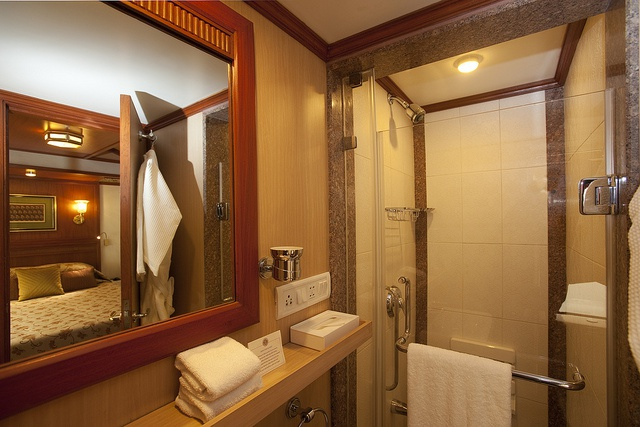Describe the objects in this image and their specific colors. I can see a bed in darkgray, olive, maroon, and tan tones in this image. 